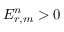<formula> <loc_0><loc_0><loc_500><loc_500>E _ { r , m } ^ { n } > 0</formula> 